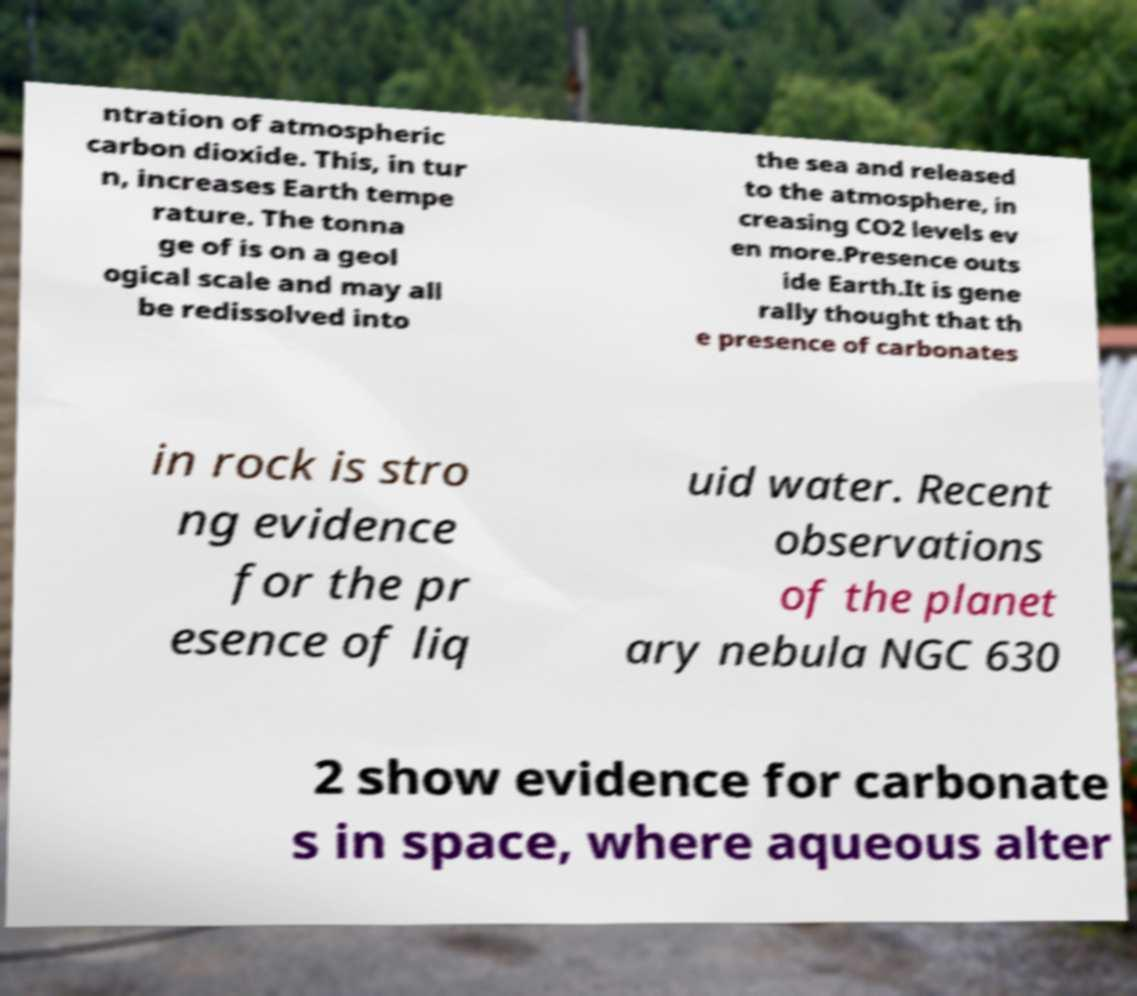Please identify and transcribe the text found in this image. ntration of atmospheric carbon dioxide. This, in tur n, increases Earth tempe rature. The tonna ge of is on a geol ogical scale and may all be redissolved into the sea and released to the atmosphere, in creasing CO2 levels ev en more.Presence outs ide Earth.It is gene rally thought that th e presence of carbonates in rock is stro ng evidence for the pr esence of liq uid water. Recent observations of the planet ary nebula NGC 630 2 show evidence for carbonate s in space, where aqueous alter 